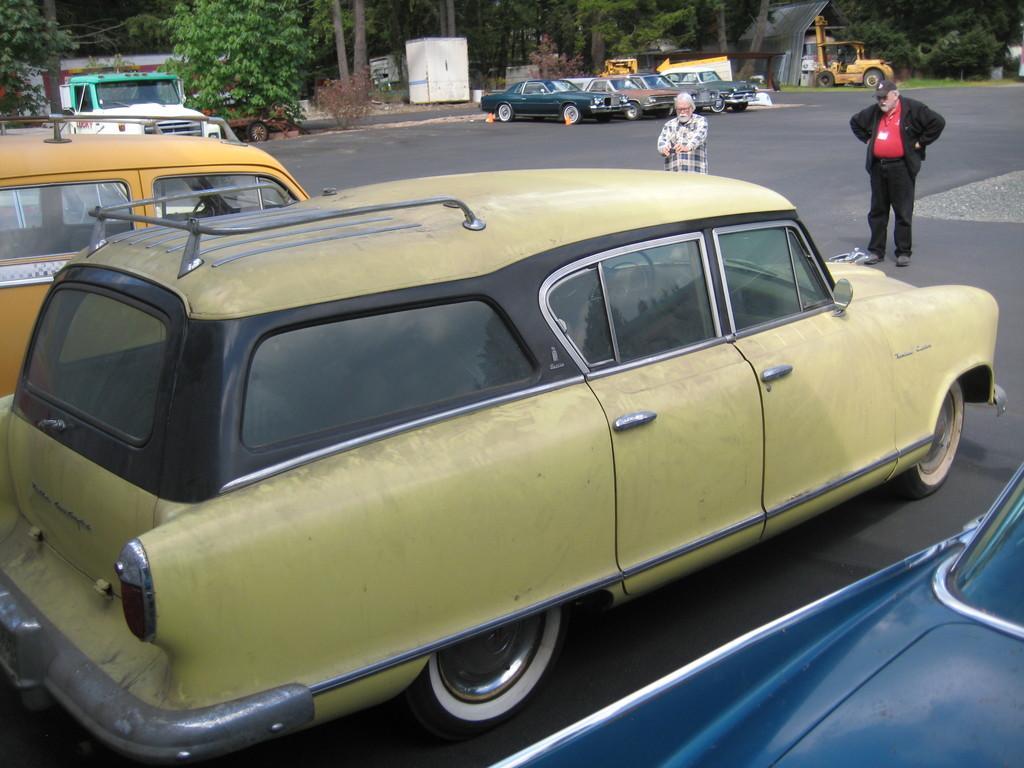Please provide a concise description of this image. In the foreground of this image, there are vehicles on the road. Behind it, there are two men standing. In the background, there are vehicles and the trees. 